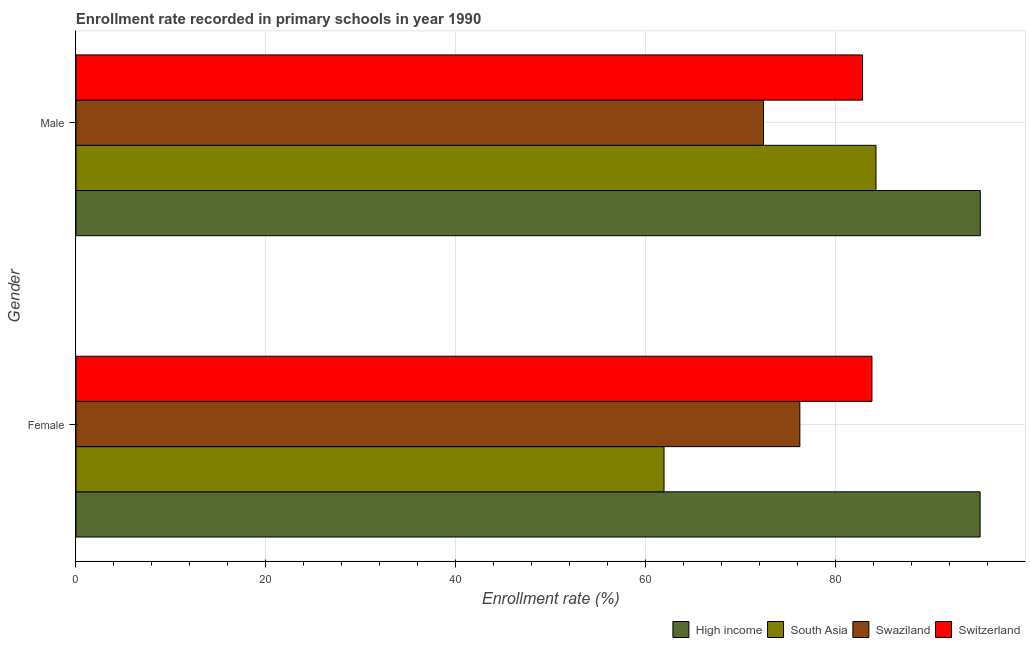How many different coloured bars are there?
Make the answer very short. 4. Are the number of bars on each tick of the Y-axis equal?
Offer a terse response. Yes. How many bars are there on the 2nd tick from the bottom?
Ensure brevity in your answer.  4. What is the enrollment rate of female students in Swaziland?
Offer a terse response. 76.24. Across all countries, what is the maximum enrollment rate of female students?
Your response must be concise. 95.22. Across all countries, what is the minimum enrollment rate of female students?
Your answer should be compact. 61.93. What is the total enrollment rate of female students in the graph?
Your response must be concise. 317.21. What is the difference between the enrollment rate of female students in Switzerland and that in South Asia?
Ensure brevity in your answer.  21.9. What is the difference between the enrollment rate of male students in Switzerland and the enrollment rate of female students in High income?
Your answer should be compact. -12.38. What is the average enrollment rate of female students per country?
Offer a terse response. 79.3. What is the difference between the enrollment rate of female students and enrollment rate of male students in Switzerland?
Provide a succinct answer. 0.99. In how many countries, is the enrollment rate of female students greater than 40 %?
Make the answer very short. 4. What is the ratio of the enrollment rate of male students in Switzerland to that in Swaziland?
Give a very brief answer. 1.14. What does the 4th bar from the top in Female represents?
Offer a very short reply. High income. What does the 4th bar from the bottom in Female represents?
Your answer should be compact. Switzerland. How many bars are there?
Provide a succinct answer. 8. How many countries are there in the graph?
Keep it short and to the point. 4. What is the difference between two consecutive major ticks on the X-axis?
Ensure brevity in your answer.  20. How are the legend labels stacked?
Your response must be concise. Horizontal. What is the title of the graph?
Make the answer very short. Enrollment rate recorded in primary schools in year 1990. Does "Marshall Islands" appear as one of the legend labels in the graph?
Give a very brief answer. No. What is the label or title of the X-axis?
Make the answer very short. Enrollment rate (%). What is the Enrollment rate (%) of High income in Female?
Make the answer very short. 95.22. What is the Enrollment rate (%) of South Asia in Female?
Keep it short and to the point. 61.93. What is the Enrollment rate (%) of Swaziland in Female?
Give a very brief answer. 76.24. What is the Enrollment rate (%) of Switzerland in Female?
Your answer should be very brief. 83.83. What is the Enrollment rate (%) of High income in Male?
Provide a succinct answer. 95.24. What is the Enrollment rate (%) in South Asia in Male?
Offer a terse response. 84.25. What is the Enrollment rate (%) of Swaziland in Male?
Give a very brief answer. 72.4. What is the Enrollment rate (%) of Switzerland in Male?
Offer a very short reply. 82.84. Across all Gender, what is the maximum Enrollment rate (%) in High income?
Make the answer very short. 95.24. Across all Gender, what is the maximum Enrollment rate (%) in South Asia?
Offer a terse response. 84.25. Across all Gender, what is the maximum Enrollment rate (%) in Swaziland?
Provide a short and direct response. 76.24. Across all Gender, what is the maximum Enrollment rate (%) of Switzerland?
Keep it short and to the point. 83.83. Across all Gender, what is the minimum Enrollment rate (%) in High income?
Offer a very short reply. 95.22. Across all Gender, what is the minimum Enrollment rate (%) in South Asia?
Your answer should be very brief. 61.93. Across all Gender, what is the minimum Enrollment rate (%) of Swaziland?
Offer a very short reply. 72.4. Across all Gender, what is the minimum Enrollment rate (%) in Switzerland?
Give a very brief answer. 82.84. What is the total Enrollment rate (%) of High income in the graph?
Your answer should be very brief. 190.46. What is the total Enrollment rate (%) in South Asia in the graph?
Provide a succinct answer. 146.18. What is the total Enrollment rate (%) of Swaziland in the graph?
Offer a very short reply. 148.64. What is the total Enrollment rate (%) of Switzerland in the graph?
Offer a terse response. 166.67. What is the difference between the Enrollment rate (%) in High income in Female and that in Male?
Provide a succinct answer. -0.02. What is the difference between the Enrollment rate (%) in South Asia in Female and that in Male?
Ensure brevity in your answer.  -22.32. What is the difference between the Enrollment rate (%) of Swaziland in Female and that in Male?
Ensure brevity in your answer.  3.83. What is the difference between the Enrollment rate (%) of High income in Female and the Enrollment rate (%) of South Asia in Male?
Provide a short and direct response. 10.97. What is the difference between the Enrollment rate (%) of High income in Female and the Enrollment rate (%) of Swaziland in Male?
Offer a terse response. 22.81. What is the difference between the Enrollment rate (%) of High income in Female and the Enrollment rate (%) of Switzerland in Male?
Provide a short and direct response. 12.38. What is the difference between the Enrollment rate (%) of South Asia in Female and the Enrollment rate (%) of Swaziland in Male?
Your answer should be compact. -10.47. What is the difference between the Enrollment rate (%) in South Asia in Female and the Enrollment rate (%) in Switzerland in Male?
Your answer should be very brief. -20.91. What is the difference between the Enrollment rate (%) in Swaziland in Female and the Enrollment rate (%) in Switzerland in Male?
Offer a terse response. -6.6. What is the average Enrollment rate (%) of High income per Gender?
Offer a very short reply. 95.23. What is the average Enrollment rate (%) of South Asia per Gender?
Your answer should be very brief. 73.09. What is the average Enrollment rate (%) in Swaziland per Gender?
Your answer should be very brief. 74.32. What is the average Enrollment rate (%) in Switzerland per Gender?
Keep it short and to the point. 83.33. What is the difference between the Enrollment rate (%) of High income and Enrollment rate (%) of South Asia in Female?
Keep it short and to the point. 33.29. What is the difference between the Enrollment rate (%) of High income and Enrollment rate (%) of Swaziland in Female?
Make the answer very short. 18.98. What is the difference between the Enrollment rate (%) of High income and Enrollment rate (%) of Switzerland in Female?
Provide a short and direct response. 11.39. What is the difference between the Enrollment rate (%) in South Asia and Enrollment rate (%) in Swaziland in Female?
Make the answer very short. -14.3. What is the difference between the Enrollment rate (%) of South Asia and Enrollment rate (%) of Switzerland in Female?
Give a very brief answer. -21.9. What is the difference between the Enrollment rate (%) in Swaziland and Enrollment rate (%) in Switzerland in Female?
Offer a terse response. -7.59. What is the difference between the Enrollment rate (%) of High income and Enrollment rate (%) of South Asia in Male?
Offer a very short reply. 10.98. What is the difference between the Enrollment rate (%) of High income and Enrollment rate (%) of Swaziland in Male?
Offer a very short reply. 22.83. What is the difference between the Enrollment rate (%) in High income and Enrollment rate (%) in Switzerland in Male?
Offer a very short reply. 12.4. What is the difference between the Enrollment rate (%) of South Asia and Enrollment rate (%) of Swaziland in Male?
Offer a terse response. 11.85. What is the difference between the Enrollment rate (%) in South Asia and Enrollment rate (%) in Switzerland in Male?
Make the answer very short. 1.41. What is the difference between the Enrollment rate (%) in Swaziland and Enrollment rate (%) in Switzerland in Male?
Provide a short and direct response. -10.43. What is the ratio of the Enrollment rate (%) of South Asia in Female to that in Male?
Offer a very short reply. 0.74. What is the ratio of the Enrollment rate (%) in Swaziland in Female to that in Male?
Your response must be concise. 1.05. What is the ratio of the Enrollment rate (%) of Switzerland in Female to that in Male?
Ensure brevity in your answer.  1.01. What is the difference between the highest and the second highest Enrollment rate (%) in High income?
Provide a short and direct response. 0.02. What is the difference between the highest and the second highest Enrollment rate (%) in South Asia?
Provide a succinct answer. 22.32. What is the difference between the highest and the second highest Enrollment rate (%) in Swaziland?
Keep it short and to the point. 3.83. What is the difference between the highest and the second highest Enrollment rate (%) in Switzerland?
Make the answer very short. 0.99. What is the difference between the highest and the lowest Enrollment rate (%) in High income?
Provide a short and direct response. 0.02. What is the difference between the highest and the lowest Enrollment rate (%) of South Asia?
Keep it short and to the point. 22.32. What is the difference between the highest and the lowest Enrollment rate (%) of Swaziland?
Keep it short and to the point. 3.83. What is the difference between the highest and the lowest Enrollment rate (%) of Switzerland?
Ensure brevity in your answer.  0.99. 